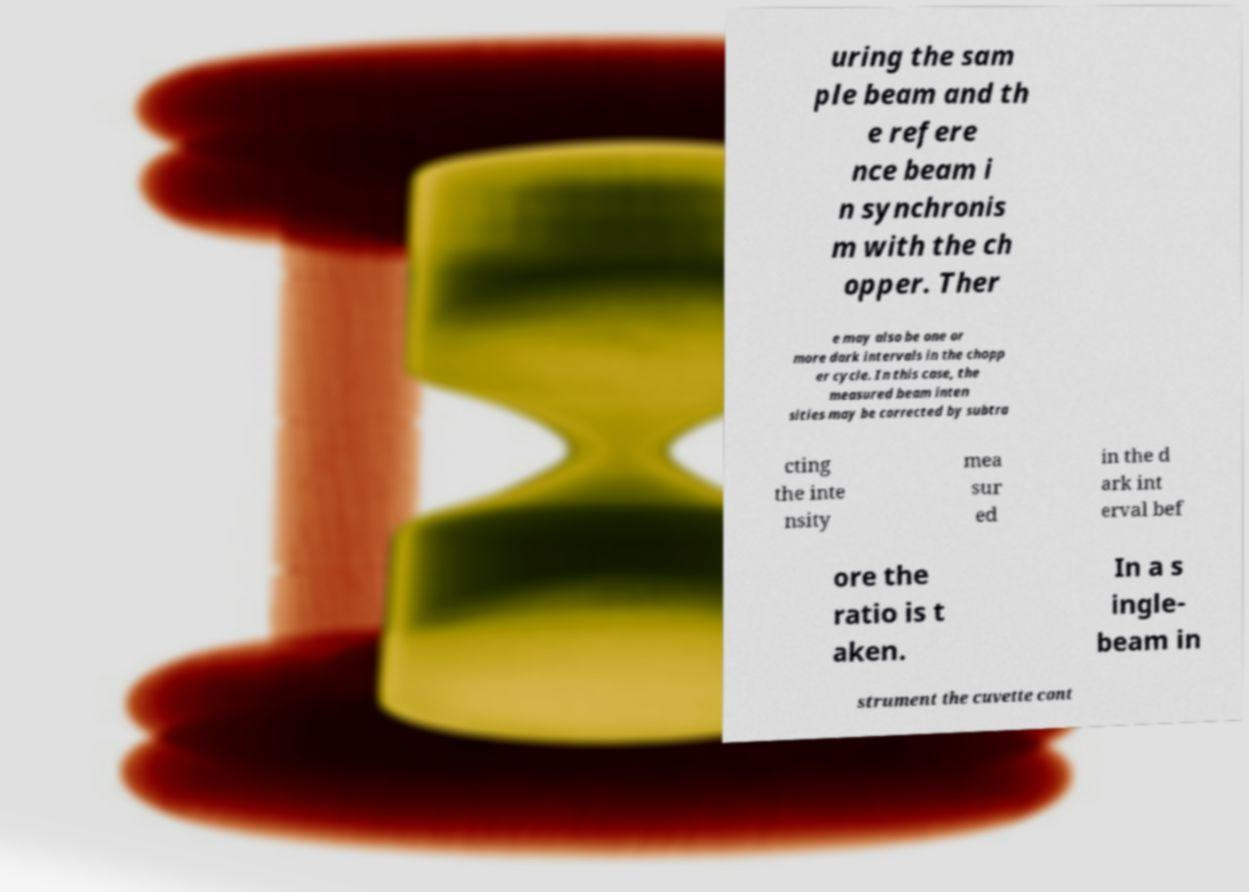There's text embedded in this image that I need extracted. Can you transcribe it verbatim? uring the sam ple beam and th e refere nce beam i n synchronis m with the ch opper. Ther e may also be one or more dark intervals in the chopp er cycle. In this case, the measured beam inten sities may be corrected by subtra cting the inte nsity mea sur ed in the d ark int erval bef ore the ratio is t aken. In a s ingle- beam in strument the cuvette cont 